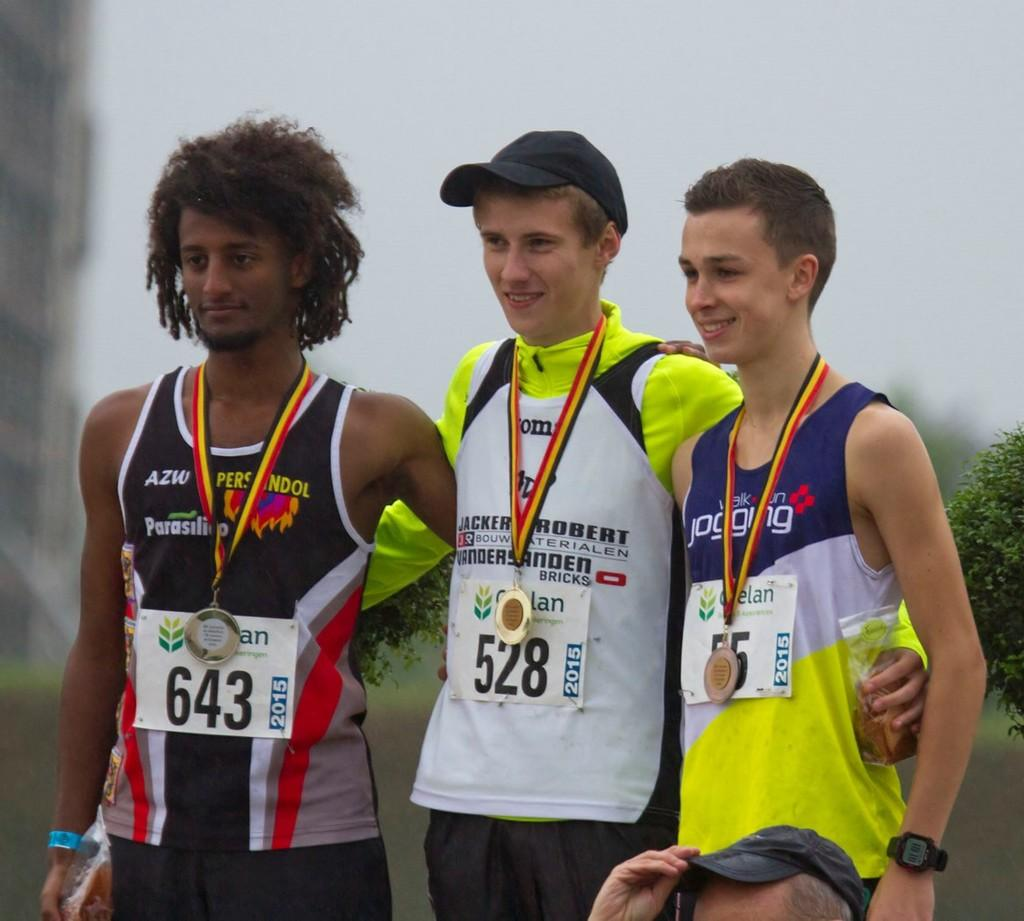<image>
Relay a brief, clear account of the picture shown. Athlete number 643 stands with two other young men as they receive medals. 